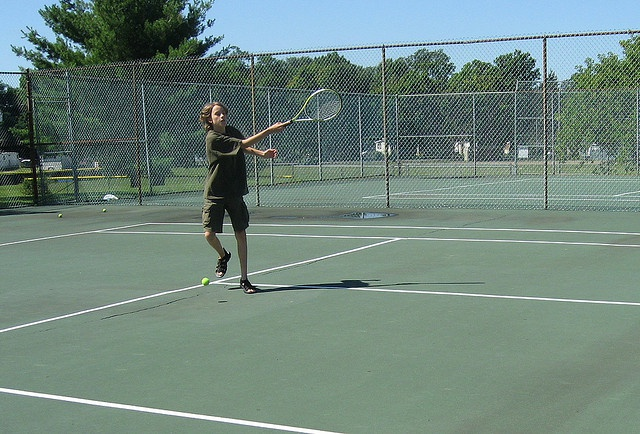Describe the objects in this image and their specific colors. I can see people in lightblue, black, gray, and darkgray tones, tennis racket in lightblue, teal, darkgray, black, and gray tones, sports ball in lightblue, khaki, green, lightgreen, and darkgreen tones, sports ball in lightblue, gray, black, darkgreen, and olive tones, and sports ball in lightblue, black, lightyellow, darkgreen, and olive tones in this image. 